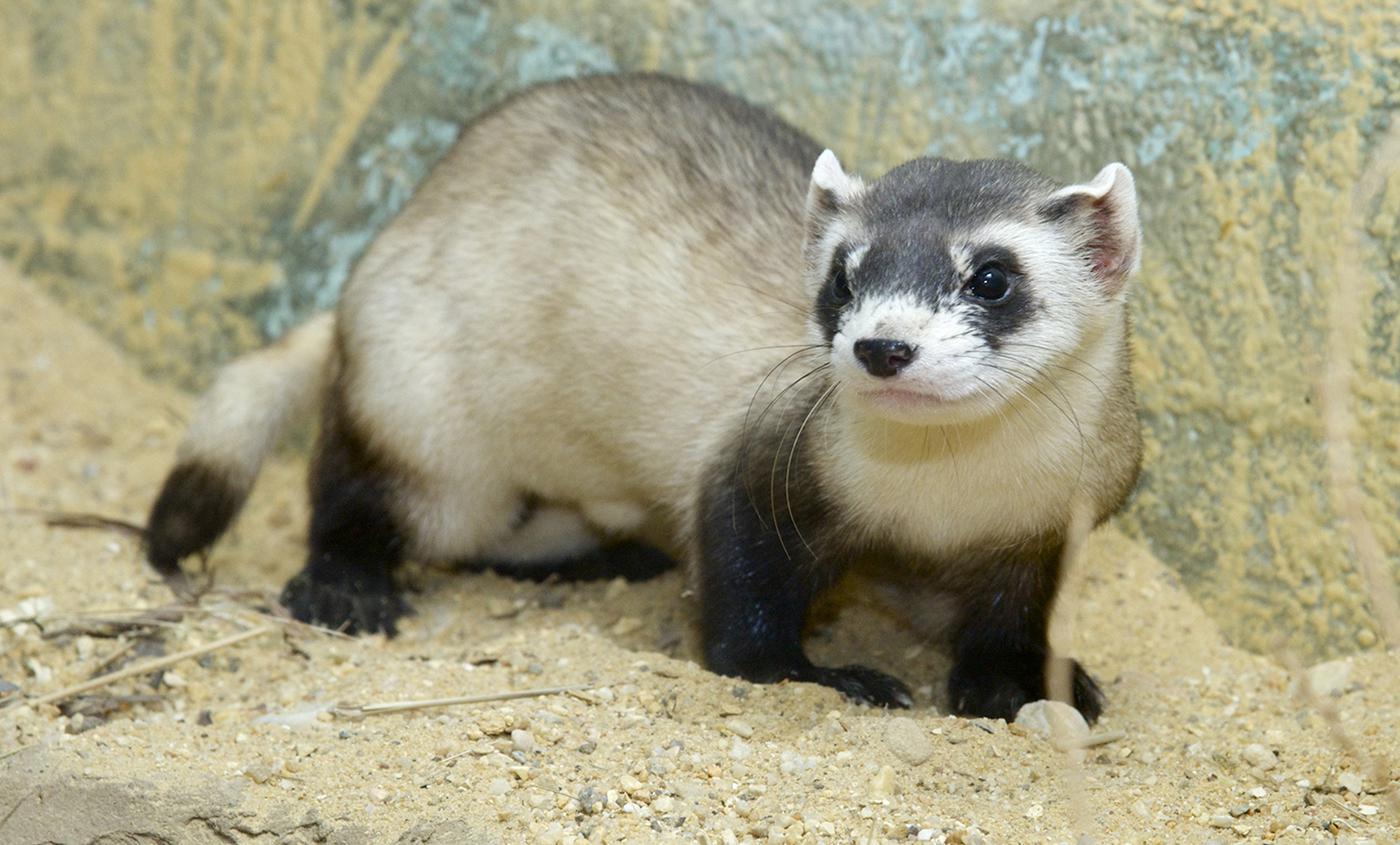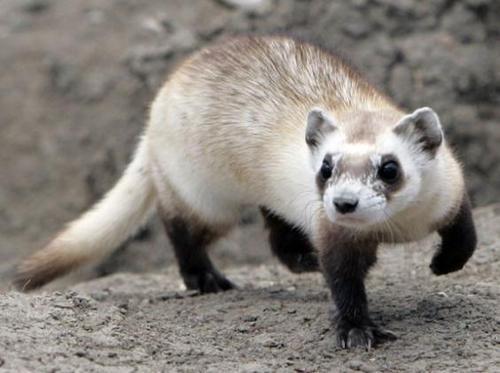The first image is the image on the left, the second image is the image on the right. For the images shown, is this caption "Right and left images show ferrets with heads facing the same direction." true? Answer yes or no. Yes. The first image is the image on the left, the second image is the image on the right. Evaluate the accuracy of this statement regarding the images: "An animal is looking to the left.". Is it true? Answer yes or no. Yes. 